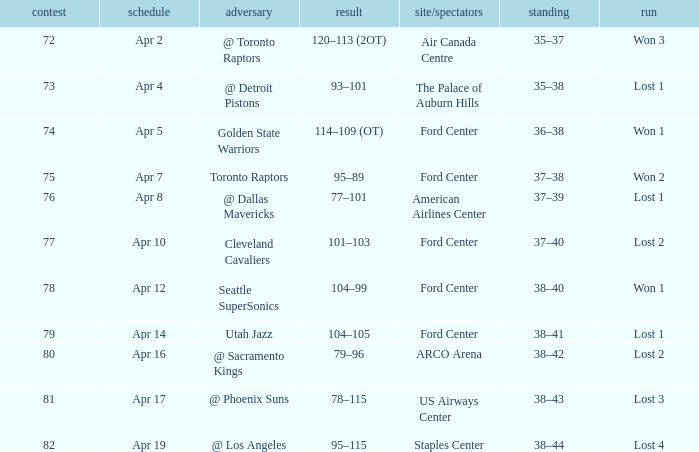What was the location when the opponent was Seattle Supersonics? Ford Center. 